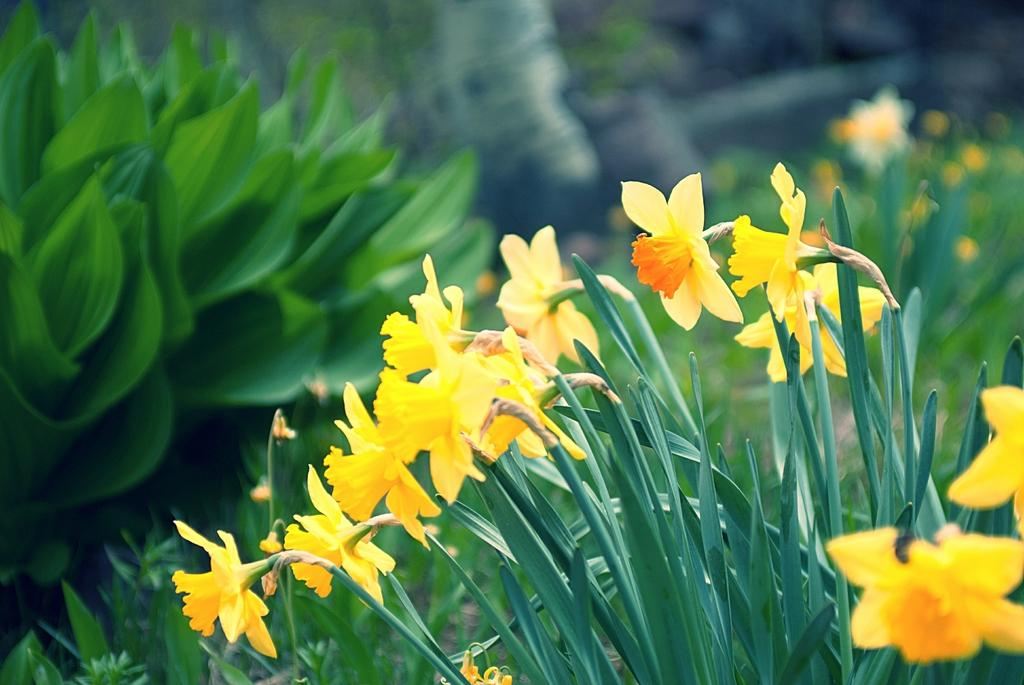What is the main subject of the image? The main subject of the image is flower plants. Where are the flower plants located in the image? The flower plants are in the center of the image. What else can be seen in the background of the image? There are leaves in the background of the image. Is there an umbrella being used to protect the flower plants from the rain in the image? There is no umbrella present in the image, and therefore no such protection can be observed. 